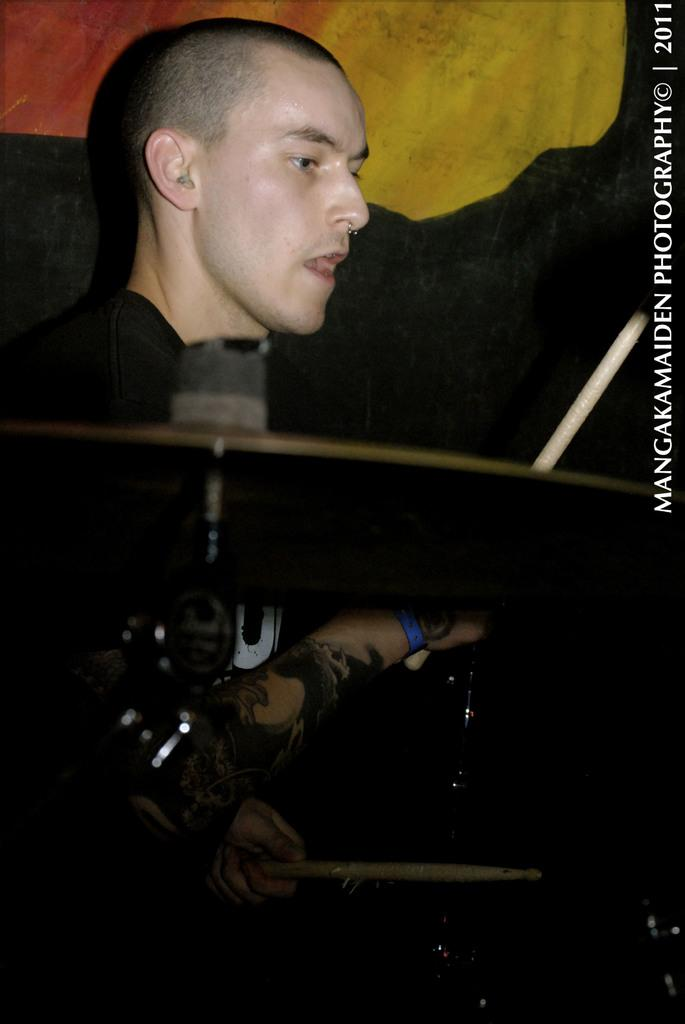What is the man in the image doing? The man is sitting in the image and holding sticks. What might the sticks be used for? The sticks are likely associated with a hi-hat instrument. Is there any additional information about the image? Yes, there is a watermark on the image. What type of cheese is the man holding in the image? There is no cheese present in the image; the man is holding sticks associated with a hi-hat instrument. 